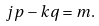Convert formula to latex. <formula><loc_0><loc_0><loc_500><loc_500>j p - k q = m .</formula> 